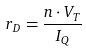Convert formula to latex. <formula><loc_0><loc_0><loc_500><loc_500>r _ { D } = \frac { n \cdot V _ { T } } { I _ { Q } }</formula> 